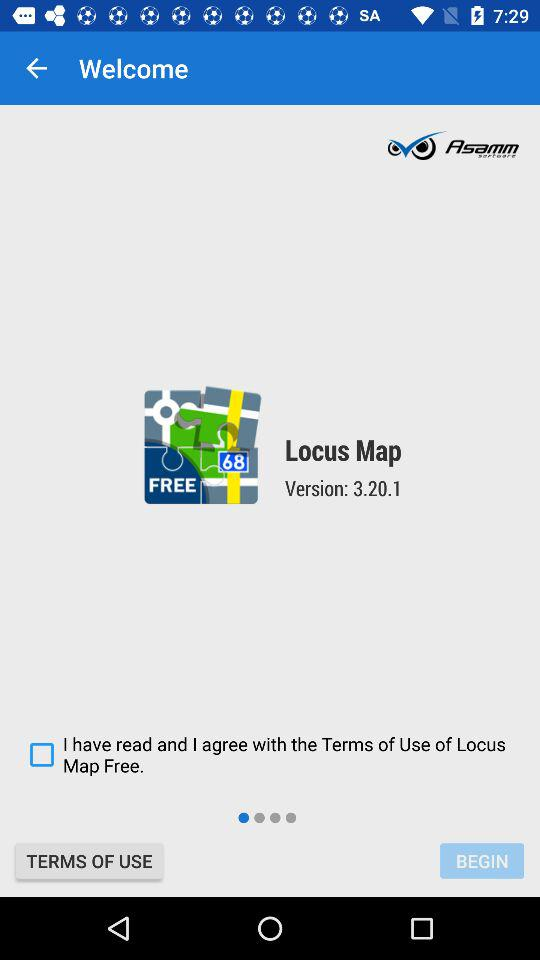What is the name of the application? The name of the application is "Locus Map". 